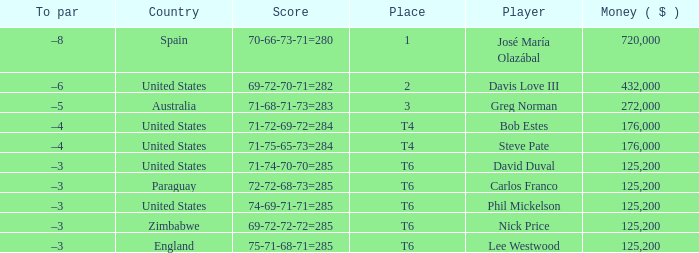Which Place has a To par of –8? 1.0. 